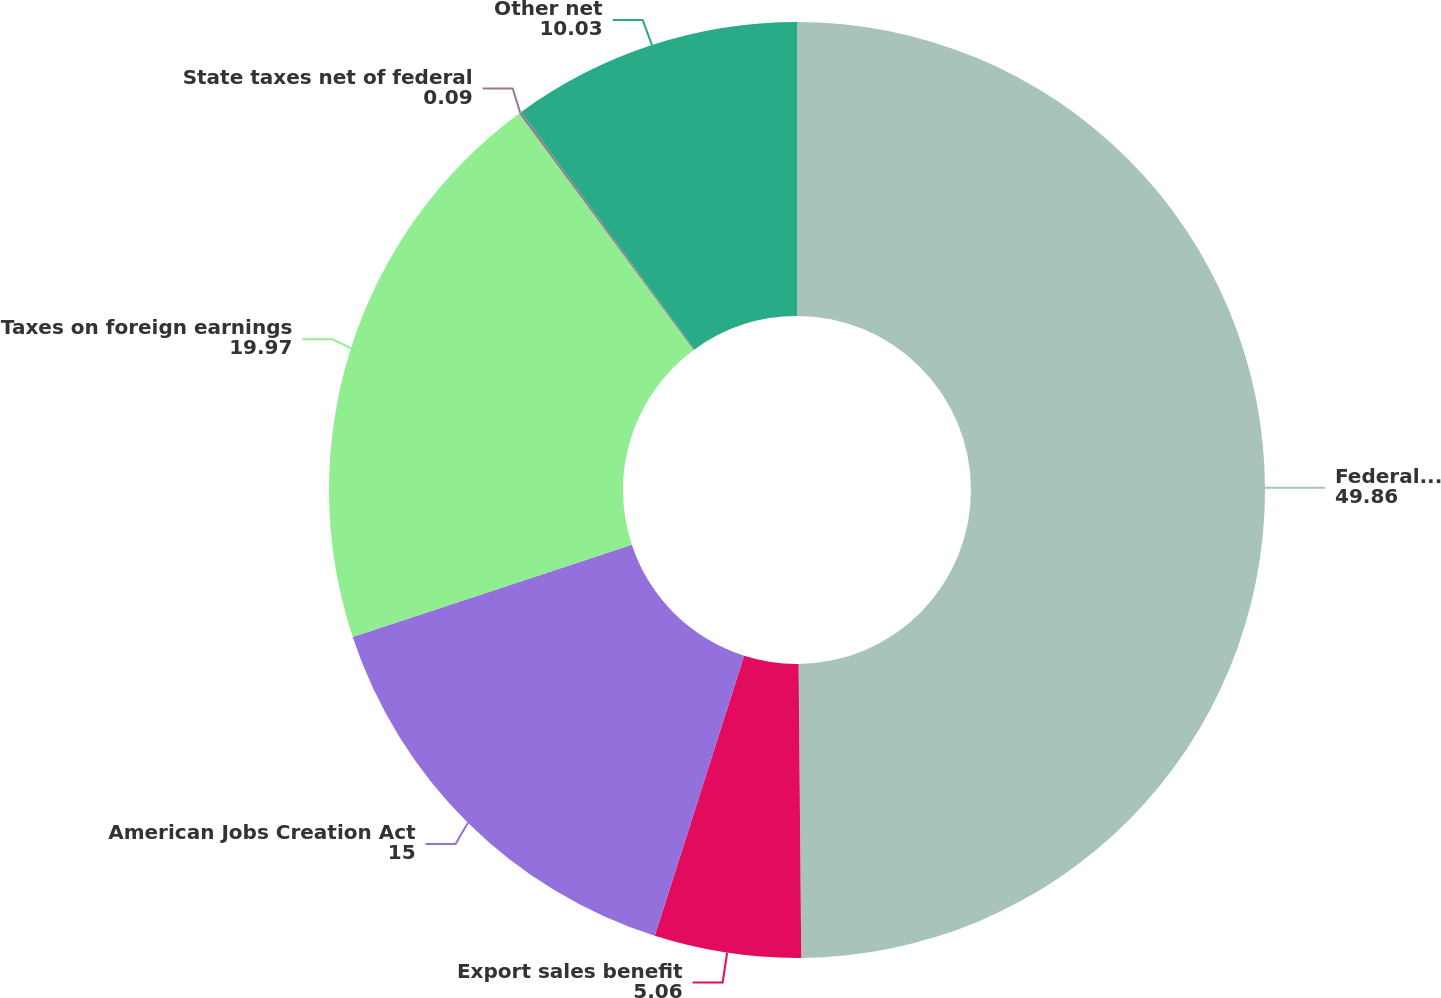Convert chart. <chart><loc_0><loc_0><loc_500><loc_500><pie_chart><fcel>Federal statutory rate<fcel>Export sales benefit<fcel>American Jobs Creation Act<fcel>Taxes on foreign earnings<fcel>State taxes net of federal<fcel>Other net<nl><fcel>49.86%<fcel>5.06%<fcel>15.0%<fcel>19.97%<fcel>0.09%<fcel>10.03%<nl></chart> 